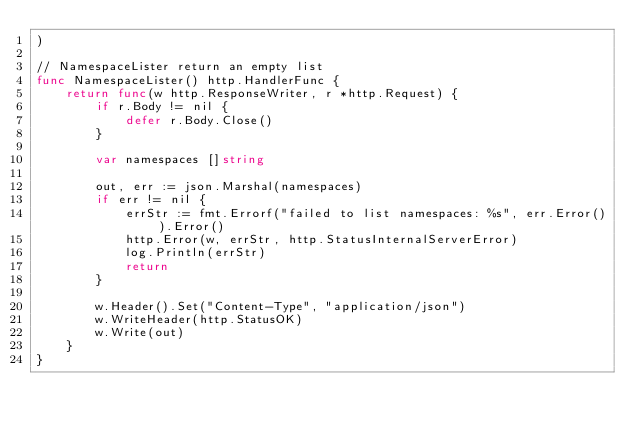<code> <loc_0><loc_0><loc_500><loc_500><_Go_>)

// NamespaceLister return an empty list
func NamespaceLister() http.HandlerFunc {
	return func(w http.ResponseWriter, r *http.Request) {
		if r.Body != nil {
			defer r.Body.Close()
		}

		var namespaces []string

		out, err := json.Marshal(namespaces)
		if err != nil {
			errStr := fmt.Errorf("failed to list namespaces: %s", err.Error()).Error()
			http.Error(w, errStr, http.StatusInternalServerError)
			log.Println(errStr)
			return
		}

		w.Header().Set("Content-Type", "application/json")
		w.WriteHeader(http.StatusOK)
		w.Write(out)
	}
}
</code> 